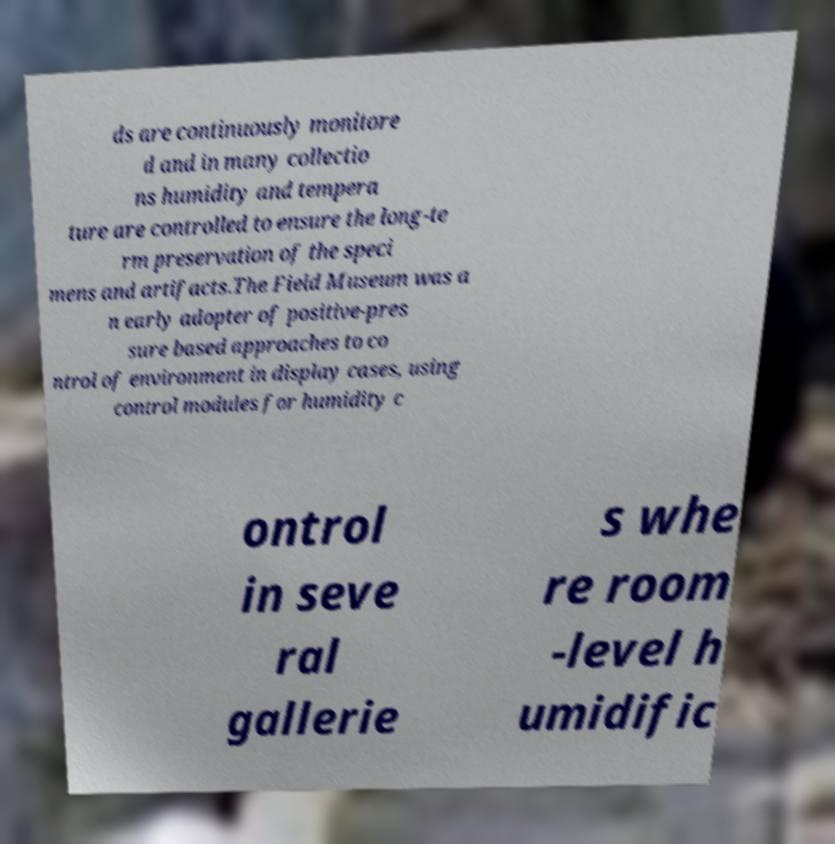Can you read and provide the text displayed in the image?This photo seems to have some interesting text. Can you extract and type it out for me? ds are continuously monitore d and in many collectio ns humidity and tempera ture are controlled to ensure the long-te rm preservation of the speci mens and artifacts.The Field Museum was a n early adopter of positive-pres sure based approaches to co ntrol of environment in display cases, using control modules for humidity c ontrol in seve ral gallerie s whe re room -level h umidific 